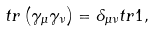<formula> <loc_0><loc_0><loc_500><loc_500>t r \left ( { \gamma _ { \mu } \gamma _ { \nu } } \right ) = \delta _ { \mu \nu } t r 1 ,</formula> 